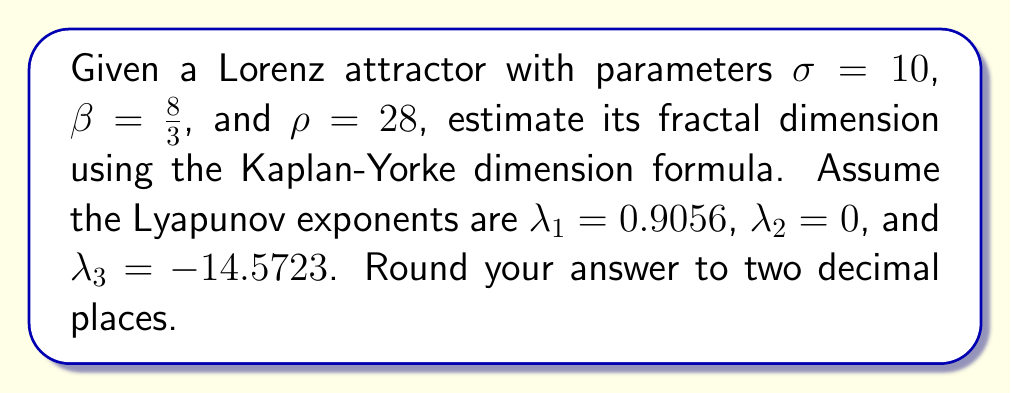What is the answer to this math problem? To estimate the fractal dimension of the Lorenz attractor, we'll use the Kaplan-Yorke dimension formula:

$$D_{KY} = j + \frac{\sum_{i=1}^j \lambda_i}{|\lambda_{j+1}|}$$

where $j$ is the largest integer such that $\sum_{i=1}^j \lambda_i \geq 0$.

Step 1: Determine $j$
$\lambda_1 + \lambda_2 = 0.9056 + 0 = 0.9056 > 0$
$\lambda_1 + \lambda_2 + \lambda_3 = 0.9056 + 0 - 14.5723 = -13.6667 < 0$
Therefore, $j = 2$

Step 2: Calculate the sum of the first $j$ Lyapunov exponents
$\sum_{i=1}^j \lambda_i = \lambda_1 + \lambda_2 = 0.9056 + 0 = 0.9056$

Step 3: Calculate $|\lambda_{j+1}|$
$|\lambda_3| = |-14.5723| = 14.5723$

Step 4: Apply the Kaplan-Yorke dimension formula
$$D_{KY} = 2 + \frac{0.9056}{14.5723} = 2.0621$$

Step 5: Round to two decimal places
$D_{KY} \approx 2.06$
Answer: 2.06 